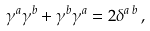<formula> <loc_0><loc_0><loc_500><loc_500>\gamma ^ { a } \gamma ^ { b } + \gamma ^ { b } \gamma ^ { a } = 2 \delta ^ { a \, b } \, ,</formula> 